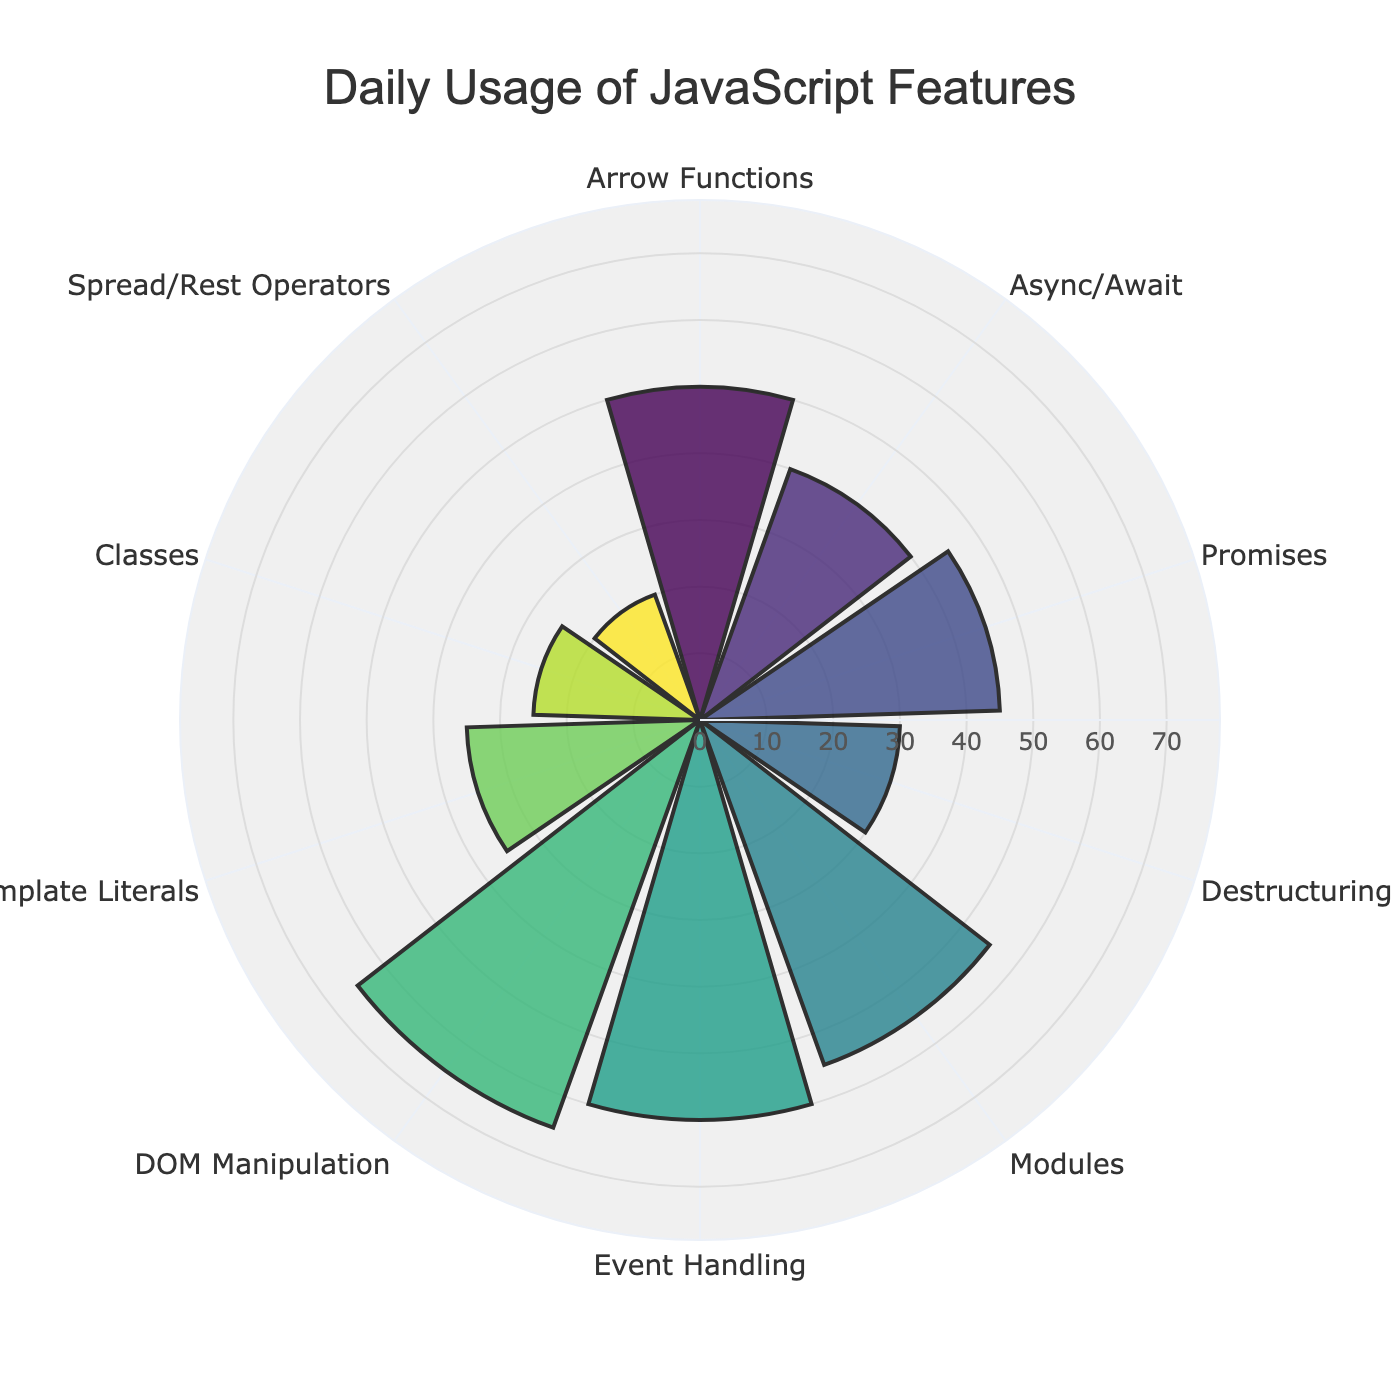What is the title of the chart? The title is located at the top center of the chart. It reads, "Daily Usage of JavaScript Features".
Answer: Daily Usage of JavaScript Features Which feature has the highest daily usage and what is the usage value? By looking at the length of the bars in the polar area chart, DOM Manipulation has the longest bar. The corresponding usage value for DOM Manipulation is 65.
Answer: DOM Manipulation, 65 How many different JavaScript features are displayed in the chart? Count all unique labels along the angular axis (theta labels). There are 10 unique feature labels shown.
Answer: 10 What is the combined daily usage of Arrow Functions and Promises? Find the usage values for Arrow Functions (50) and Promises (45), then add them together: 50 + 45 = 95.
Answer: 95 Which feature has the lowest daily usage and what is the usage value? The shortest bar represents the feature with the lowest usage, which is Spread/Rest Operators with a usage value of 20.
Answer: Spread/Rest Operators, 20 How does the usage of Event Handling compare to Modules? From the chart, Event Handling has a bar slightly shorter than DOM Manipulation. Modules have a shorter bar compared to Event Handling. The usage values are 60 for Event Handling and 55 for Modules. Thus, Event Handling has a higher usage than Modules.
Answer: Event Handling is higher What is the average daily usage of all the features? To calculate the average, sum all the usage values and divide by the number of features: (50 + 40 + 45 + 30 + 55 + 60 + 65 + 35 + 25 + 20) / 10 = 425 / 10 = 42.5.
Answer: 42.5 What is the difference in daily usage between Template Literals and Classes? Subtract the usage value for Classes (25) from Template Literals (35): 35 - 25 = 10.
Answer: 10 What is the total daily usage for Destructuring, Classes, and Spread/Rest Operators combined? Add the usage values for Destructuring (30), Classes (25), and Spread/Rest Operators (20): 30 + 25 + 20 = 75.
Answer: 75 Are there more features with usage values above or below the average usage? The average usage value is 42.5. Count the features with usage values above this average (4: Arrow Functions, Promises, Modules, Event Handling, DOM Manipulation) and those below this average (6: Async/Await, Destructuring, Template Literals, Classes, Spread/Rest Operators). There are more features below the average usage.
Answer: Below the average 